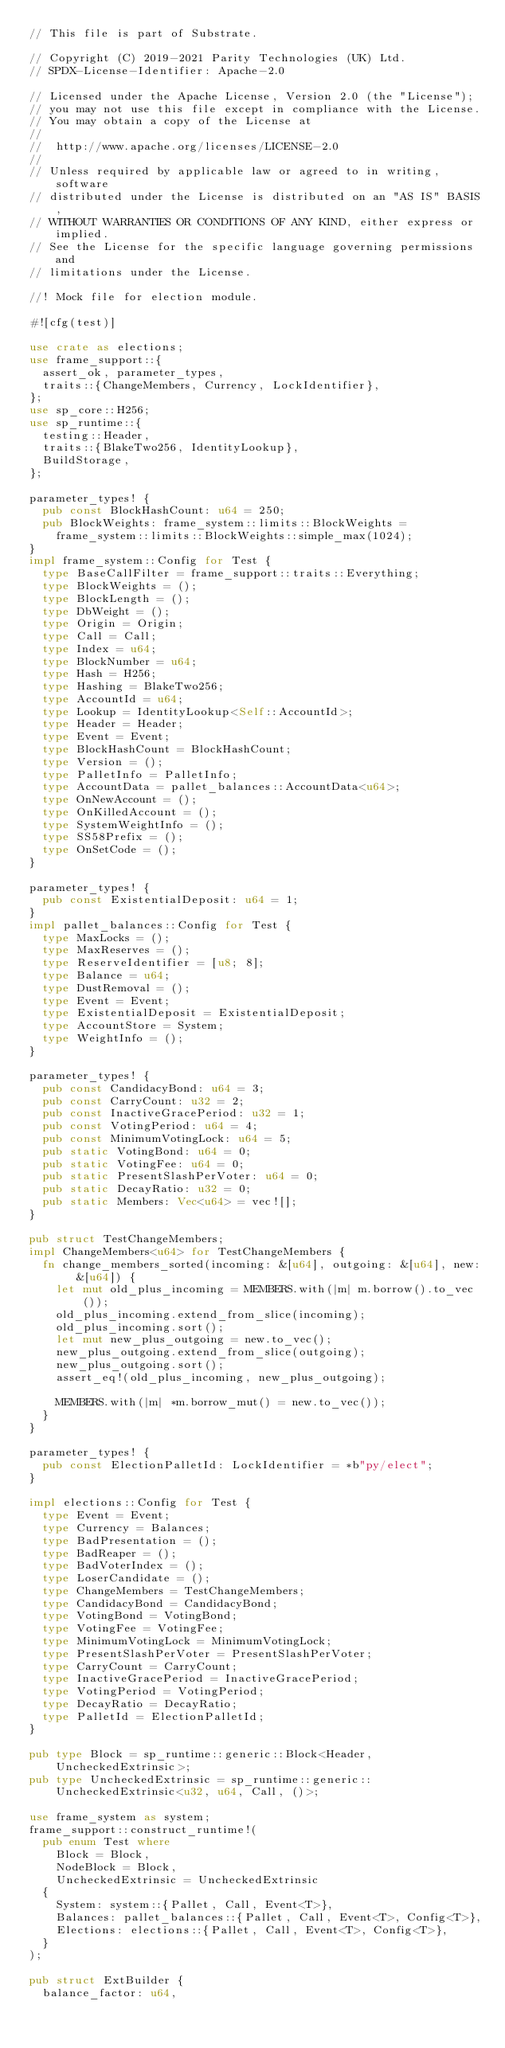Convert code to text. <code><loc_0><loc_0><loc_500><loc_500><_Rust_>// This file is part of Substrate.

// Copyright (C) 2019-2021 Parity Technologies (UK) Ltd.
// SPDX-License-Identifier: Apache-2.0

// Licensed under the Apache License, Version 2.0 (the "License");
// you may not use this file except in compliance with the License.
// You may obtain a copy of the License at
//
// 	http://www.apache.org/licenses/LICENSE-2.0
//
// Unless required by applicable law or agreed to in writing, software
// distributed under the License is distributed on an "AS IS" BASIS,
// WITHOUT WARRANTIES OR CONDITIONS OF ANY KIND, either express or implied.
// See the License for the specific language governing permissions and
// limitations under the License.

//! Mock file for election module.

#![cfg(test)]

use crate as elections;
use frame_support::{
	assert_ok, parameter_types,
	traits::{ChangeMembers, Currency, LockIdentifier},
};
use sp_core::H256;
use sp_runtime::{
	testing::Header,
	traits::{BlakeTwo256, IdentityLookup},
	BuildStorage,
};

parameter_types! {
	pub const BlockHashCount: u64 = 250;
	pub BlockWeights: frame_system::limits::BlockWeights =
		frame_system::limits::BlockWeights::simple_max(1024);
}
impl frame_system::Config for Test {
	type BaseCallFilter = frame_support::traits::Everything;
	type BlockWeights = ();
	type BlockLength = ();
	type DbWeight = ();
	type Origin = Origin;
	type Call = Call;
	type Index = u64;
	type BlockNumber = u64;
	type Hash = H256;
	type Hashing = BlakeTwo256;
	type AccountId = u64;
	type Lookup = IdentityLookup<Self::AccountId>;
	type Header = Header;
	type Event = Event;
	type BlockHashCount = BlockHashCount;
	type Version = ();
	type PalletInfo = PalletInfo;
	type AccountData = pallet_balances::AccountData<u64>;
	type OnNewAccount = ();
	type OnKilledAccount = ();
	type SystemWeightInfo = ();
	type SS58Prefix = ();
	type OnSetCode = ();
}

parameter_types! {
	pub const ExistentialDeposit: u64 = 1;
}
impl pallet_balances::Config for Test {
	type MaxLocks = ();
	type MaxReserves = ();
	type ReserveIdentifier = [u8; 8];
	type Balance = u64;
	type DustRemoval = ();
	type Event = Event;
	type ExistentialDeposit = ExistentialDeposit;
	type AccountStore = System;
	type WeightInfo = ();
}

parameter_types! {
	pub const CandidacyBond: u64 = 3;
	pub const CarryCount: u32 = 2;
	pub const InactiveGracePeriod: u32 = 1;
	pub const VotingPeriod: u64 = 4;
	pub const MinimumVotingLock: u64 = 5;
	pub static VotingBond: u64 = 0;
	pub static VotingFee: u64 = 0;
	pub static PresentSlashPerVoter: u64 = 0;
	pub static DecayRatio: u32 = 0;
	pub static Members: Vec<u64> = vec![];
}

pub struct TestChangeMembers;
impl ChangeMembers<u64> for TestChangeMembers {
	fn change_members_sorted(incoming: &[u64], outgoing: &[u64], new: &[u64]) {
		let mut old_plus_incoming = MEMBERS.with(|m| m.borrow().to_vec());
		old_plus_incoming.extend_from_slice(incoming);
		old_plus_incoming.sort();
		let mut new_plus_outgoing = new.to_vec();
		new_plus_outgoing.extend_from_slice(outgoing);
		new_plus_outgoing.sort();
		assert_eq!(old_plus_incoming, new_plus_outgoing);

		MEMBERS.with(|m| *m.borrow_mut() = new.to_vec());
	}
}

parameter_types! {
	pub const ElectionPalletId: LockIdentifier = *b"py/elect";
}

impl elections::Config for Test {
	type Event = Event;
	type Currency = Balances;
	type BadPresentation = ();
	type BadReaper = ();
	type BadVoterIndex = ();
	type LoserCandidate = ();
	type ChangeMembers = TestChangeMembers;
	type CandidacyBond = CandidacyBond;
	type VotingBond = VotingBond;
	type VotingFee = VotingFee;
	type MinimumVotingLock = MinimumVotingLock;
	type PresentSlashPerVoter = PresentSlashPerVoter;
	type CarryCount = CarryCount;
	type InactiveGracePeriod = InactiveGracePeriod;
	type VotingPeriod = VotingPeriod;
	type DecayRatio = DecayRatio;
	type PalletId = ElectionPalletId;
}

pub type Block = sp_runtime::generic::Block<Header, UncheckedExtrinsic>;
pub type UncheckedExtrinsic = sp_runtime::generic::UncheckedExtrinsic<u32, u64, Call, ()>;

use frame_system as system;
frame_support::construct_runtime!(
	pub enum Test where
		Block = Block,
		NodeBlock = Block,
		UncheckedExtrinsic = UncheckedExtrinsic
	{
		System: system::{Pallet, Call, Event<T>},
		Balances: pallet_balances::{Pallet, Call, Event<T>, Config<T>},
		Elections: elections::{Pallet, Call, Event<T>, Config<T>},
	}
);

pub struct ExtBuilder {
	balance_factor: u64,</code> 